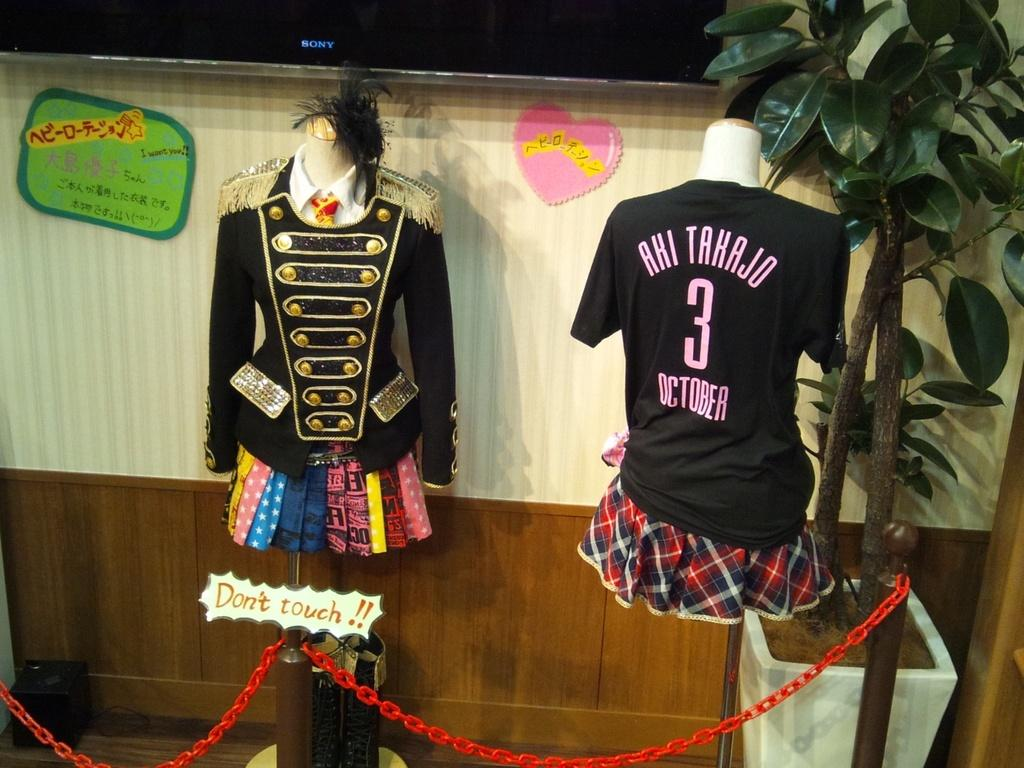Provide a one-sentence caption for the provided image. Aki Tahajo October shirt with number 3 on the back in the middle. 